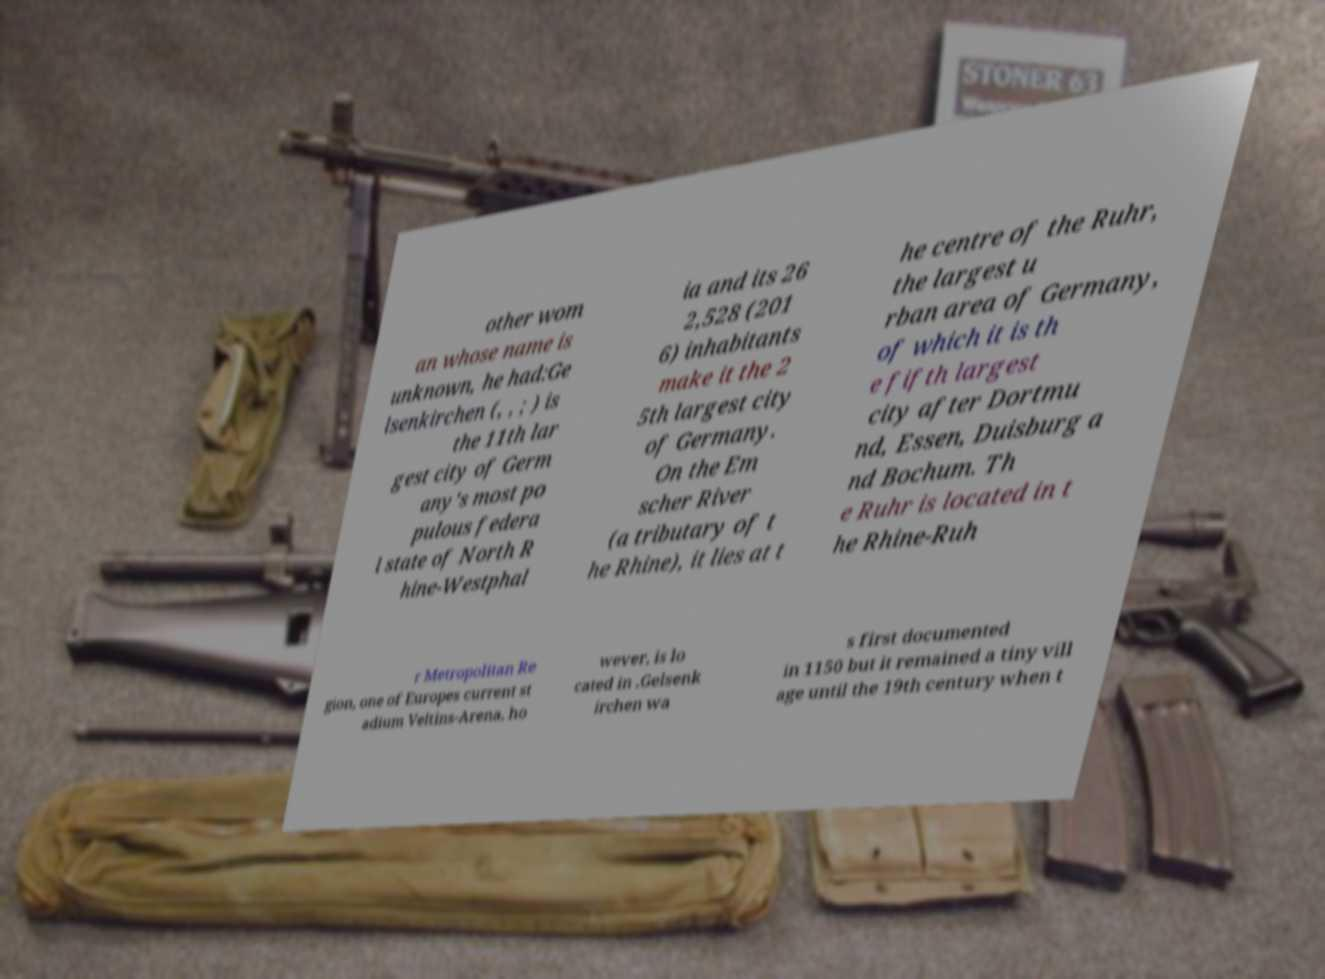What messages or text are displayed in this image? I need them in a readable, typed format. other wom an whose name is unknown, he had:Ge lsenkirchen (, , ; ) is the 11th lar gest city of Germ any's most po pulous federa l state of North R hine-Westphal ia and its 26 2,528 (201 6) inhabitants make it the 2 5th largest city of Germany. On the Em scher River (a tributary of t he Rhine), it lies at t he centre of the Ruhr, the largest u rban area of Germany, of which it is th e fifth largest city after Dortmu nd, Essen, Duisburg a nd Bochum. Th e Ruhr is located in t he Rhine-Ruh r Metropolitan Re gion, one of Europes current st adium Veltins-Arena, ho wever, is lo cated in .Gelsenk irchen wa s first documented in 1150 but it remained a tiny vill age until the 19th century when t 